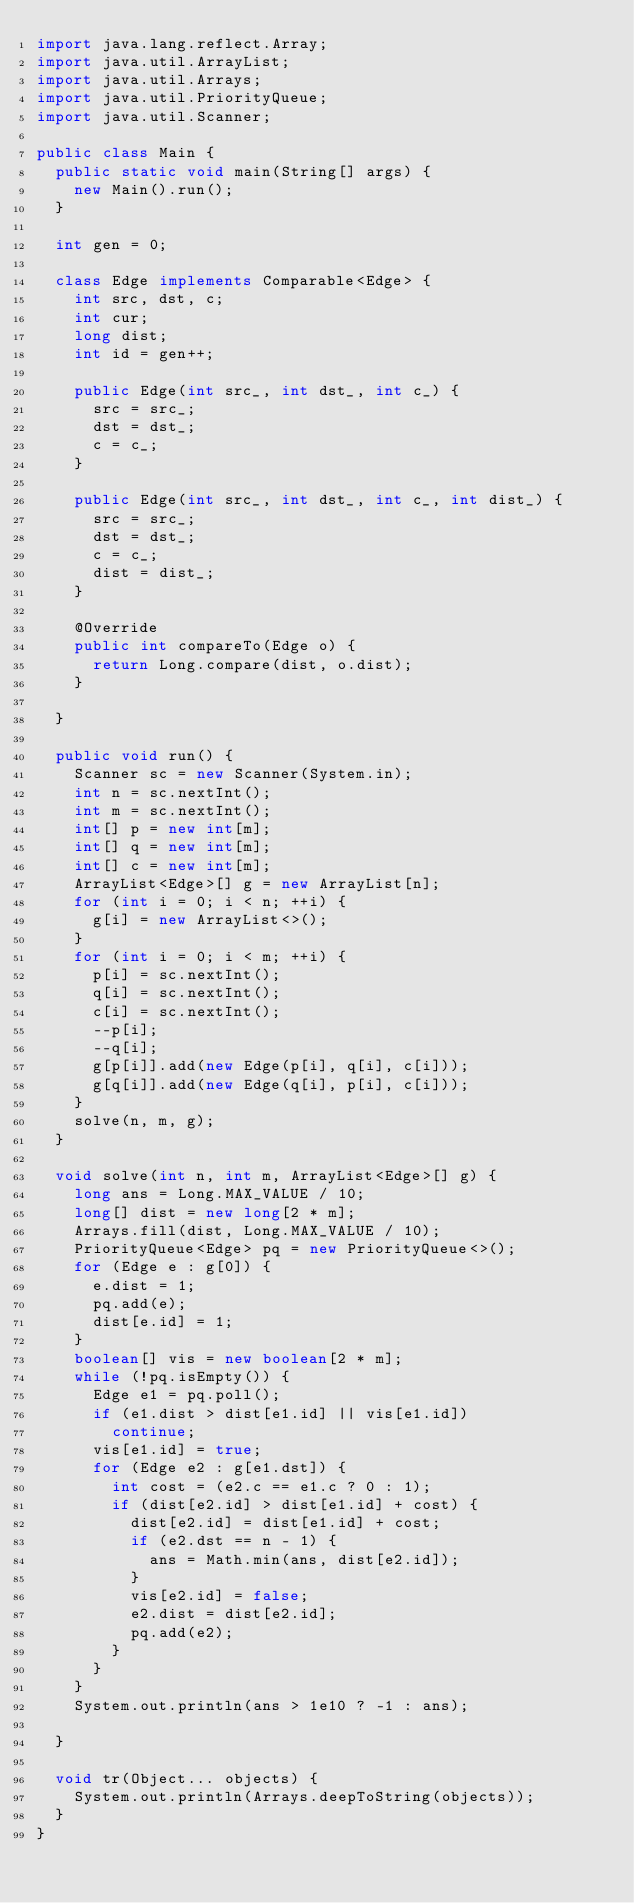Convert code to text. <code><loc_0><loc_0><loc_500><loc_500><_Java_>import java.lang.reflect.Array;
import java.util.ArrayList;
import java.util.Arrays;
import java.util.PriorityQueue;
import java.util.Scanner;

public class Main {
	public static void main(String[] args) {
		new Main().run();
	}

	int gen = 0;

	class Edge implements Comparable<Edge> {
		int src, dst, c;
		int cur;
		long dist;
		int id = gen++;

		public Edge(int src_, int dst_, int c_) {
			src = src_;
			dst = dst_;
			c = c_;
		}

		public Edge(int src_, int dst_, int c_, int dist_) {
			src = src_;
			dst = dst_;
			c = c_;
			dist = dist_;
		}

		@Override
		public int compareTo(Edge o) {
			return Long.compare(dist, o.dist);
		}

	}

	public void run() {
		Scanner sc = new Scanner(System.in);
		int n = sc.nextInt();
		int m = sc.nextInt();
		int[] p = new int[m];
		int[] q = new int[m];
		int[] c = new int[m];
		ArrayList<Edge>[] g = new ArrayList[n];
		for (int i = 0; i < n; ++i) {
			g[i] = new ArrayList<>();
		}
		for (int i = 0; i < m; ++i) {
			p[i] = sc.nextInt();
			q[i] = sc.nextInt();
			c[i] = sc.nextInt();
			--p[i];
			--q[i];
			g[p[i]].add(new Edge(p[i], q[i], c[i]));
			g[q[i]].add(new Edge(q[i], p[i], c[i]));
		}
		solve(n, m, g);
	}

	void solve(int n, int m, ArrayList<Edge>[] g) {
		long ans = Long.MAX_VALUE / 10;
		long[] dist = new long[2 * m];
		Arrays.fill(dist, Long.MAX_VALUE / 10);
		PriorityQueue<Edge> pq = new PriorityQueue<>();
		for (Edge e : g[0]) {
			e.dist = 1;
			pq.add(e);
			dist[e.id] = 1;
		}
		boolean[] vis = new boolean[2 * m];
		while (!pq.isEmpty()) {
			Edge e1 = pq.poll();
			if (e1.dist > dist[e1.id] || vis[e1.id])
				continue;
			vis[e1.id] = true;
			for (Edge e2 : g[e1.dst]) {
				int cost = (e2.c == e1.c ? 0 : 1);
				if (dist[e2.id] > dist[e1.id] + cost) {
					dist[e2.id] = dist[e1.id] + cost;
					if (e2.dst == n - 1) {
						ans = Math.min(ans, dist[e2.id]);
					}
					vis[e2.id] = false;
					e2.dist = dist[e2.id];
					pq.add(e2);
				}
			}
		}
		System.out.println(ans > 1e10 ? -1 : ans);

	}

	void tr(Object... objects) {
		System.out.println(Arrays.deepToString(objects));
	}
}
</code> 